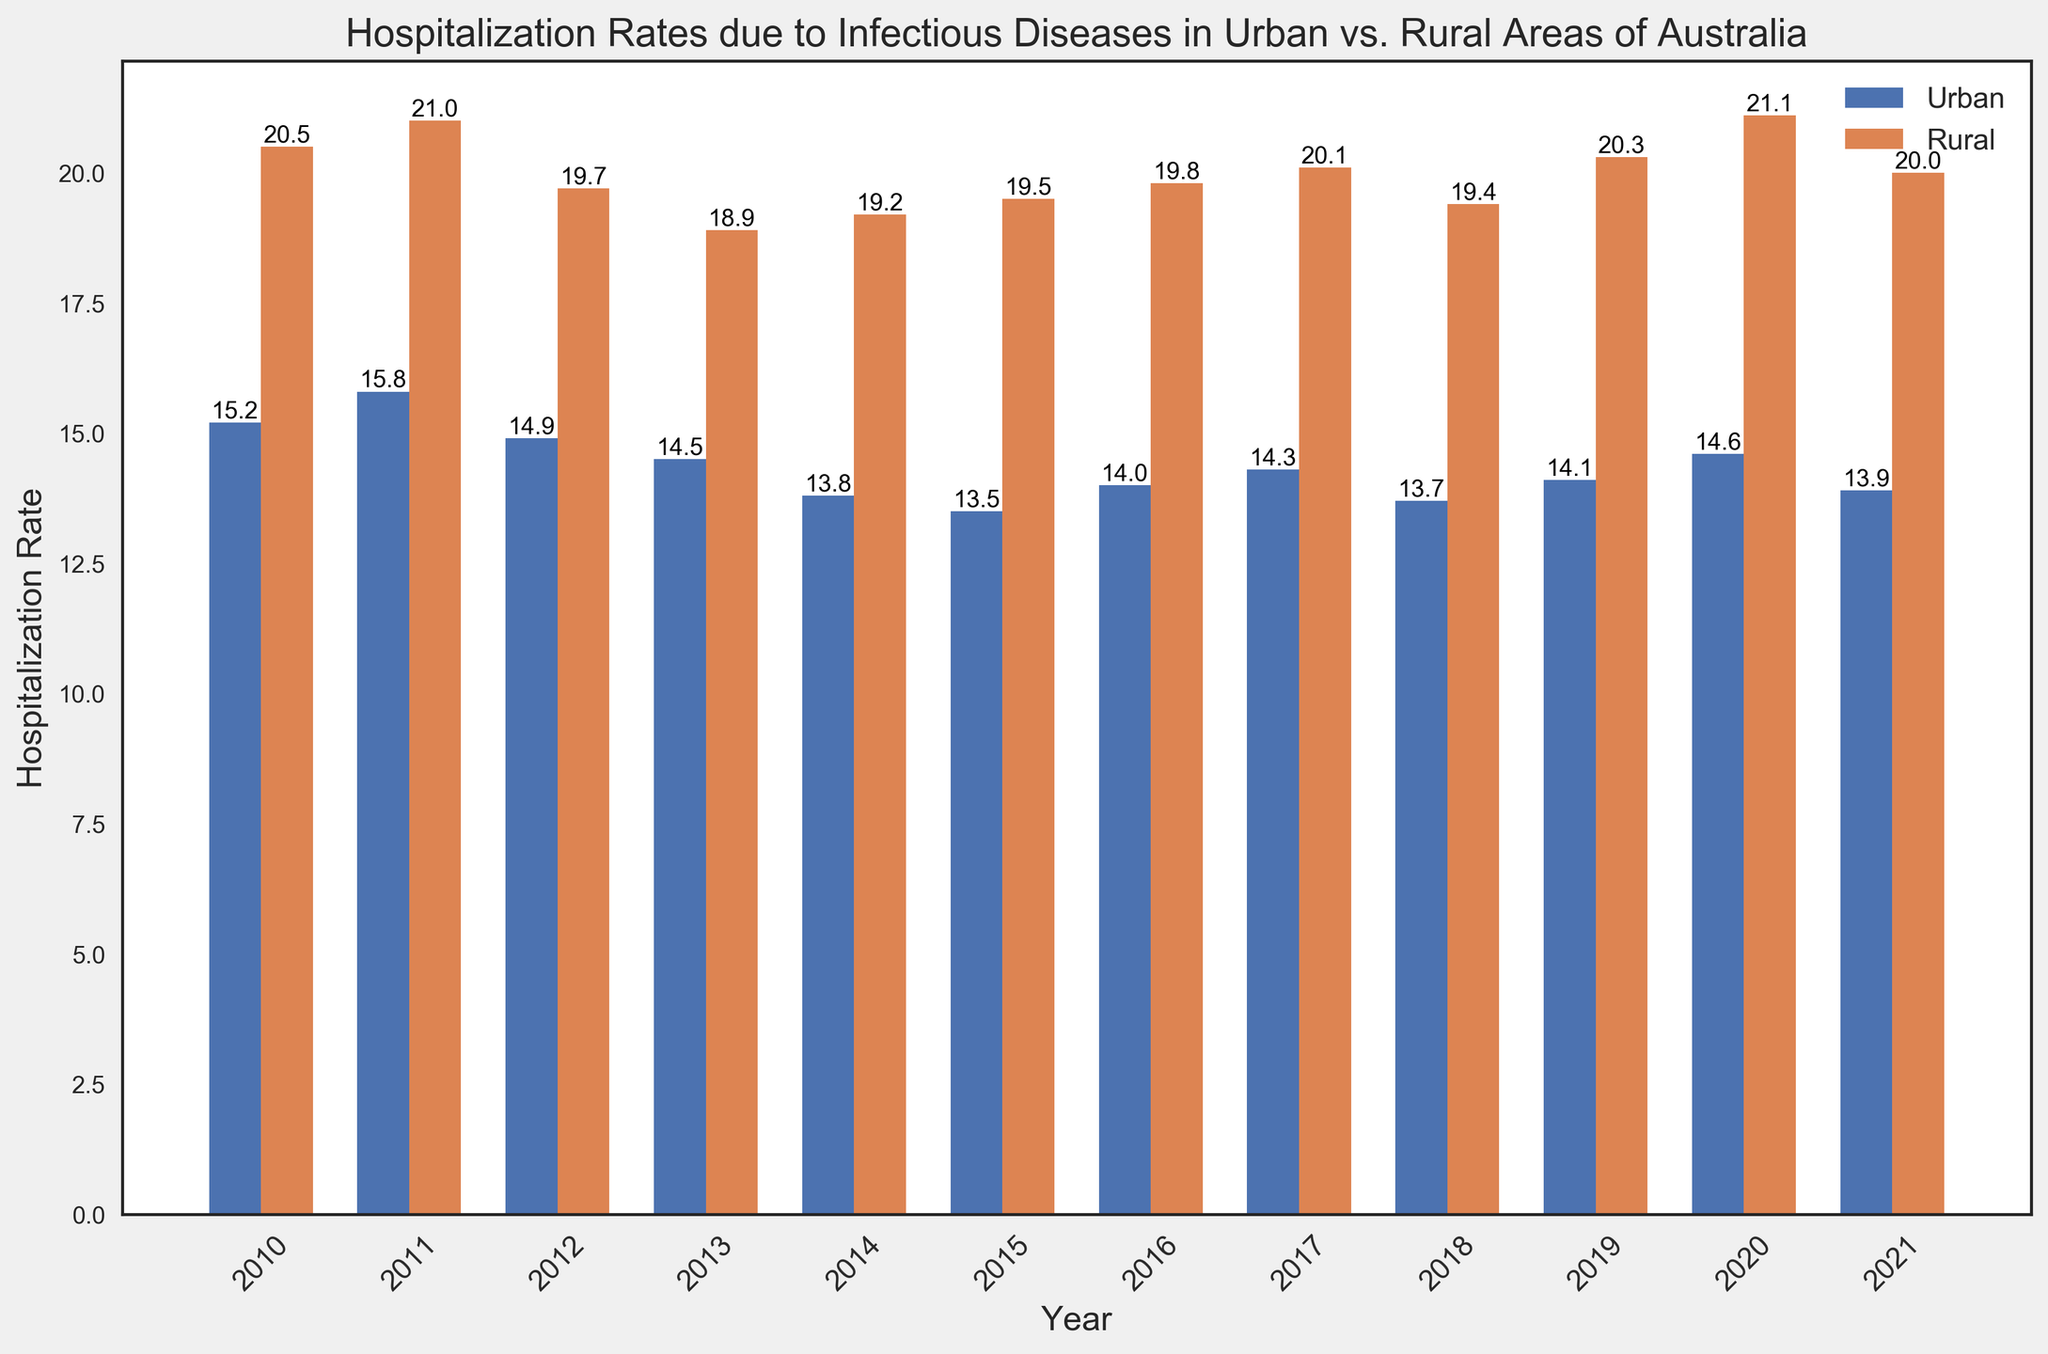What's the difference in hospitalization rates between urban and rural areas in 2013? Look at the height of the bars for 2013. The urban hospitalization rate is 14.5, and the rural rate is 18.9. Subtract the urban from the rural: 18.9 - 14.5 = 4.4
Answer: 4.4 Which year shows the highest hospitalization rate in rural areas? Identify the tallest bar in the "Rural" section, which corresponds to the year above it. The tallest "Rural" bar is in 2020 with a hospitalization rate of 21.1
Answer: 2020 In which year did the hospitalization rates in urban areas experience the lowest value? Find the shortest bar in the "Urban" section and note the corresponding year above it. The shortest bar is from 2015 with a rate of 13.5
Answer: 2015 By how much did the hospitalization rate in urban areas change from 2010 to 2021? Identify the urban hospitalization rates for both years (2010: 15.2 and 2021: 13.9) and calculate the difference: 15.2 - 13.9 = 1.3
Answer: 1.3 Is there any year where the hospitalization rate was the same for both urban and rural areas? Scan through the bars and their values for both categories. It appears in no year were the values identical between urban and rural rates.
Answer: No Which area consistently had higher hospitalization rates over the years? Compare the relative height of the bars for urban and rural each year. Rural bars were consistently taller each year, indicating higher hospitalization rates.
Answer: Rural How much did the hospitalization rate in rural areas fluctuate between 2010 and 2021? Find the highest and lowest rural hospitalization rates in the data (highest: 21.1 in 2020, lowest: 18.9 in 2013), then calculate the difference: 21.1 - 18.9 = 2.2
Answer: 2.2 What visual indication helps to quickly differentiate between urban and rural bars? Examine the colors of the bars: Urban areas are represented by blue bars, and rural areas by orange bars.
Answer: Color What's the average hospitalization rate for urban areas across all years? Add all the urban rates (15.2 + 15.8 + 14.9 + 14.5 + 13.8 + 13.5 + 14.0 + 14.3 + 13.7 + 14.1 + 14.6 + 13.9) = 177.3, then divide by the number of years (12): 177.3 / 12 = 14.775
Answer: 14.8 